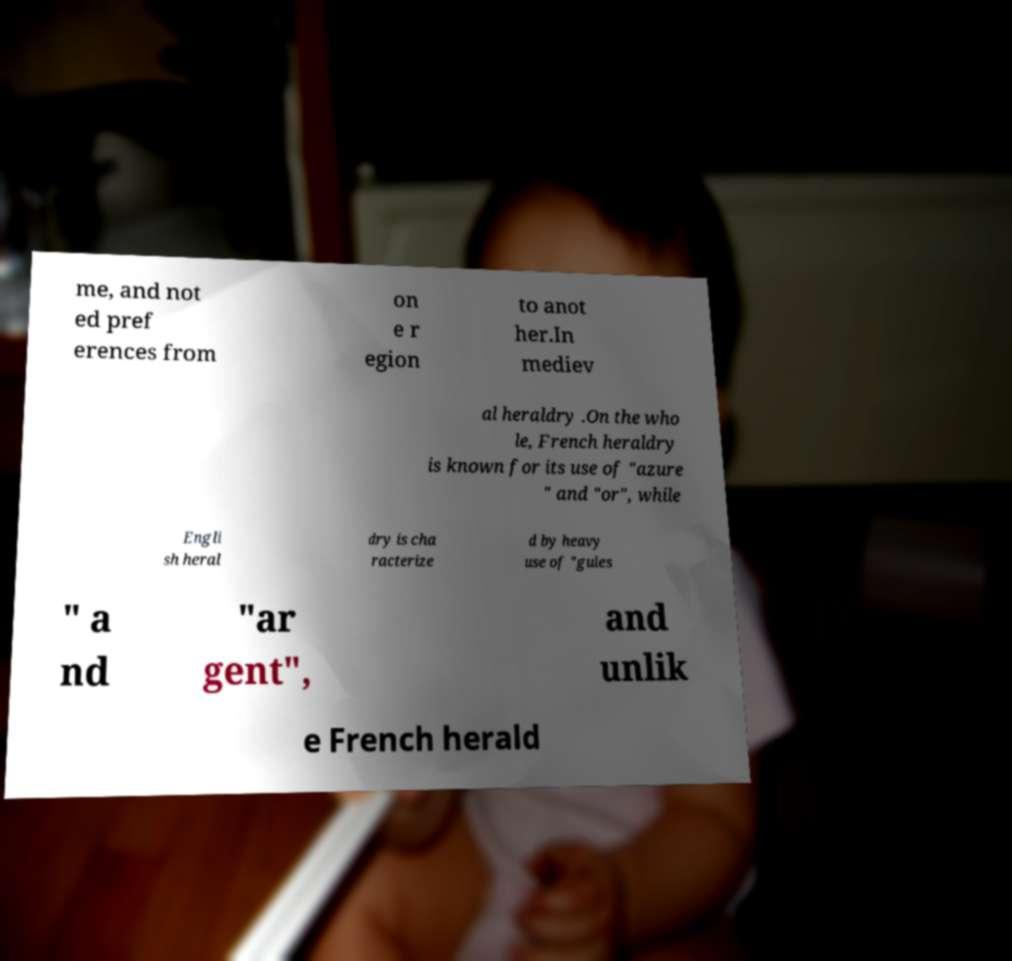For documentation purposes, I need the text within this image transcribed. Could you provide that? me, and not ed pref erences from on e r egion to anot her.In mediev al heraldry .On the who le, French heraldry is known for its use of "azure " and "or", while Engli sh heral dry is cha racterize d by heavy use of "gules " a nd "ar gent", and unlik e French herald 